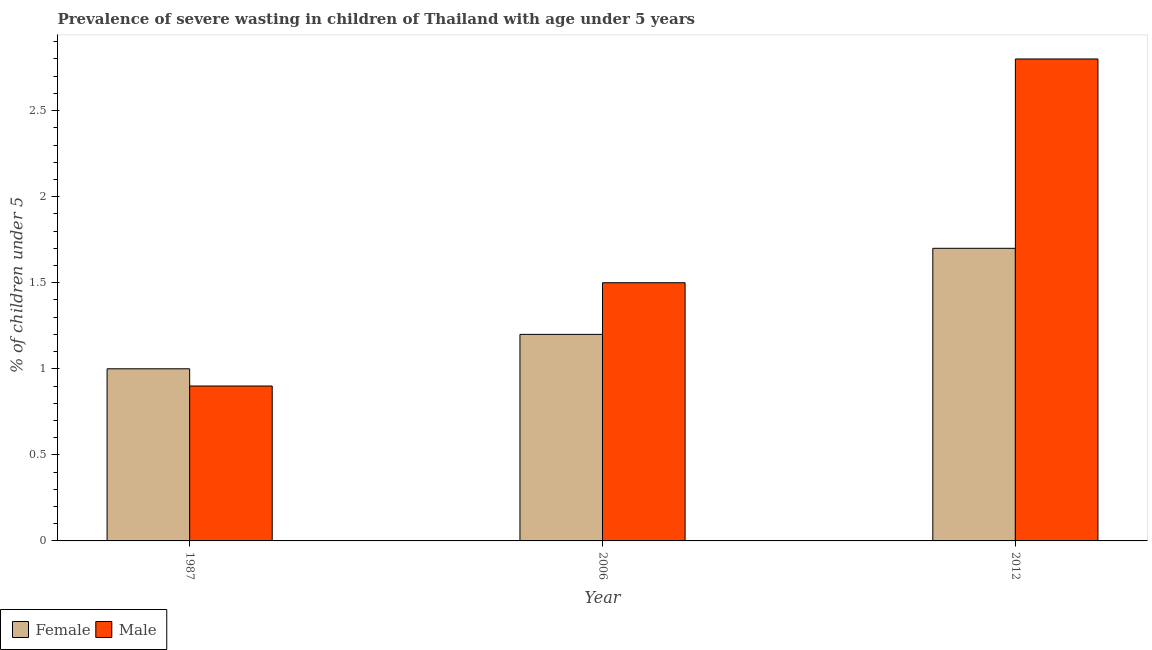How many different coloured bars are there?
Keep it short and to the point. 2. Are the number of bars per tick equal to the number of legend labels?
Offer a very short reply. Yes. Are the number of bars on each tick of the X-axis equal?
Ensure brevity in your answer.  Yes. In how many cases, is the number of bars for a given year not equal to the number of legend labels?
Your answer should be compact. 0. Across all years, what is the maximum percentage of undernourished male children?
Keep it short and to the point. 2.8. Across all years, what is the minimum percentage of undernourished female children?
Your response must be concise. 1. What is the total percentage of undernourished male children in the graph?
Keep it short and to the point. 5.2. What is the difference between the percentage of undernourished male children in 1987 and that in 2012?
Give a very brief answer. -1.9. What is the difference between the percentage of undernourished female children in 1987 and the percentage of undernourished male children in 2006?
Your answer should be compact. -0.2. What is the average percentage of undernourished male children per year?
Offer a terse response. 1.73. In the year 1987, what is the difference between the percentage of undernourished male children and percentage of undernourished female children?
Offer a very short reply. 0. In how many years, is the percentage of undernourished female children greater than 2.6 %?
Keep it short and to the point. 0. What is the ratio of the percentage of undernourished female children in 1987 to that in 2012?
Your answer should be compact. 0.59. What is the difference between the highest and the second highest percentage of undernourished male children?
Give a very brief answer. 1.3. What is the difference between the highest and the lowest percentage of undernourished female children?
Keep it short and to the point. 0.7. What does the 1st bar from the right in 1987 represents?
Offer a very short reply. Male. How many bars are there?
Offer a terse response. 6. How many years are there in the graph?
Make the answer very short. 3. Does the graph contain any zero values?
Your answer should be very brief. No. Where does the legend appear in the graph?
Make the answer very short. Bottom left. How many legend labels are there?
Keep it short and to the point. 2. How are the legend labels stacked?
Your answer should be compact. Horizontal. What is the title of the graph?
Your answer should be very brief. Prevalence of severe wasting in children of Thailand with age under 5 years. Does "Lowest 10% of population" appear as one of the legend labels in the graph?
Give a very brief answer. No. What is the label or title of the Y-axis?
Keep it short and to the point.  % of children under 5. What is the  % of children under 5 of Male in 1987?
Provide a short and direct response. 0.9. What is the  % of children under 5 of Female in 2006?
Your answer should be compact. 1.2. What is the  % of children under 5 in Male in 2006?
Make the answer very short. 1.5. What is the  % of children under 5 in Female in 2012?
Your answer should be very brief. 1.7. What is the  % of children under 5 in Male in 2012?
Keep it short and to the point. 2.8. Across all years, what is the maximum  % of children under 5 in Female?
Keep it short and to the point. 1.7. Across all years, what is the maximum  % of children under 5 in Male?
Provide a succinct answer. 2.8. Across all years, what is the minimum  % of children under 5 of Female?
Offer a terse response. 1. Across all years, what is the minimum  % of children under 5 of Male?
Make the answer very short. 0.9. What is the total  % of children under 5 in Female in the graph?
Keep it short and to the point. 3.9. What is the total  % of children under 5 of Male in the graph?
Offer a terse response. 5.2. What is the difference between the  % of children under 5 in Female in 1987 and that in 2012?
Give a very brief answer. -0.7. What is the difference between the  % of children under 5 of Male in 1987 and that in 2012?
Offer a very short reply. -1.9. What is the difference between the  % of children under 5 of Female in 2006 and that in 2012?
Keep it short and to the point. -0.5. What is the difference between the  % of children under 5 of Male in 2006 and that in 2012?
Provide a succinct answer. -1.3. What is the difference between the  % of children under 5 of Female in 1987 and the  % of children under 5 of Male in 2006?
Provide a succinct answer. -0.5. What is the average  % of children under 5 in Male per year?
Ensure brevity in your answer.  1.73. In the year 1987, what is the difference between the  % of children under 5 of Female and  % of children under 5 of Male?
Your answer should be very brief. 0.1. What is the ratio of the  % of children under 5 of Female in 1987 to that in 2012?
Provide a short and direct response. 0.59. What is the ratio of the  % of children under 5 in Male in 1987 to that in 2012?
Ensure brevity in your answer.  0.32. What is the ratio of the  % of children under 5 in Female in 2006 to that in 2012?
Keep it short and to the point. 0.71. What is the ratio of the  % of children under 5 in Male in 2006 to that in 2012?
Provide a short and direct response. 0.54. 